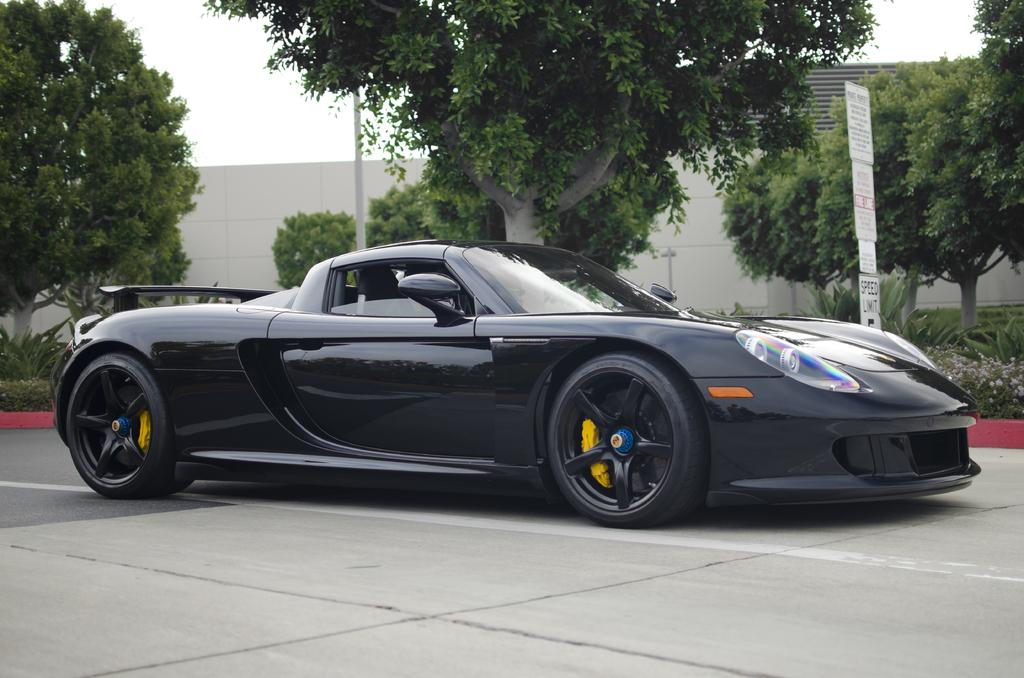What is the main subject of the image? There is a car in the image. What type of natural elements can be seen in the image? There are trees and plants in the image. What type of man-made structure is present in the image? There is a building in the image. What type of signage is present in the image? There are boards with text in the image. What is the weather like in the image? The sky is cloudy in the image. What type of sweater is the grandfather wearing in the image? There is no grandfather or sweater present in the image. 